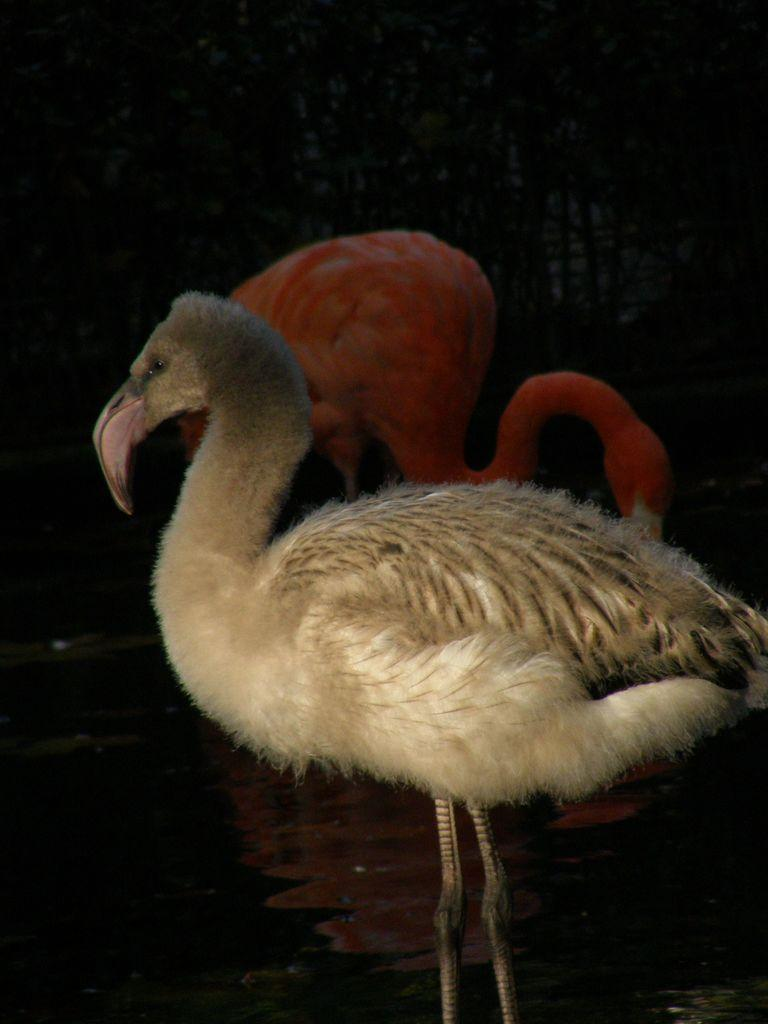How many birds are present in the image? There are two birds in the image. What is located at the bottom of the image? There is a pond at the bottom of the image. What can be seen in the background of the image? There are trees in the background of the image. What type of thread is being used by the cow in the image? There is no cow present in the image, so there is no thread being used. 